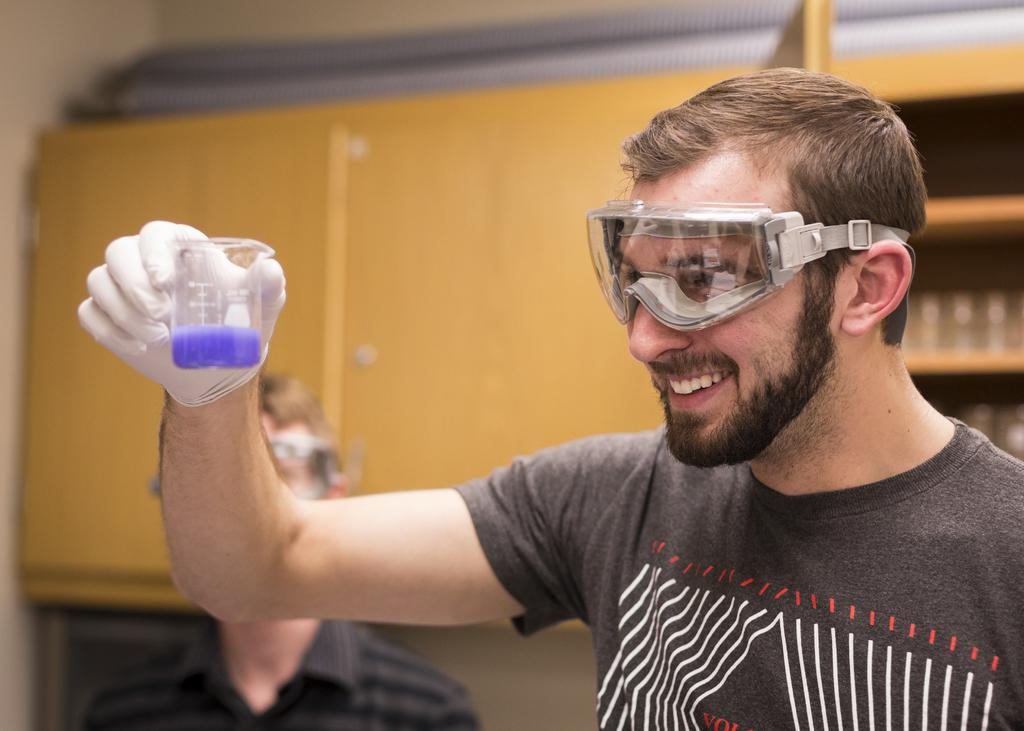What is the person in the image holding? The person in the image is holding a glass. What is the person wearing in the image? The person is wearing a gray shirt. Can you describe the background of the image? There is another person standing in the background of the image, and there are brown-colored cupboards. How many rabbits are visible in the image? There are no rabbits visible in the image. What note is the person holding in the image? The person is holding a glass, not a note, in the image. 